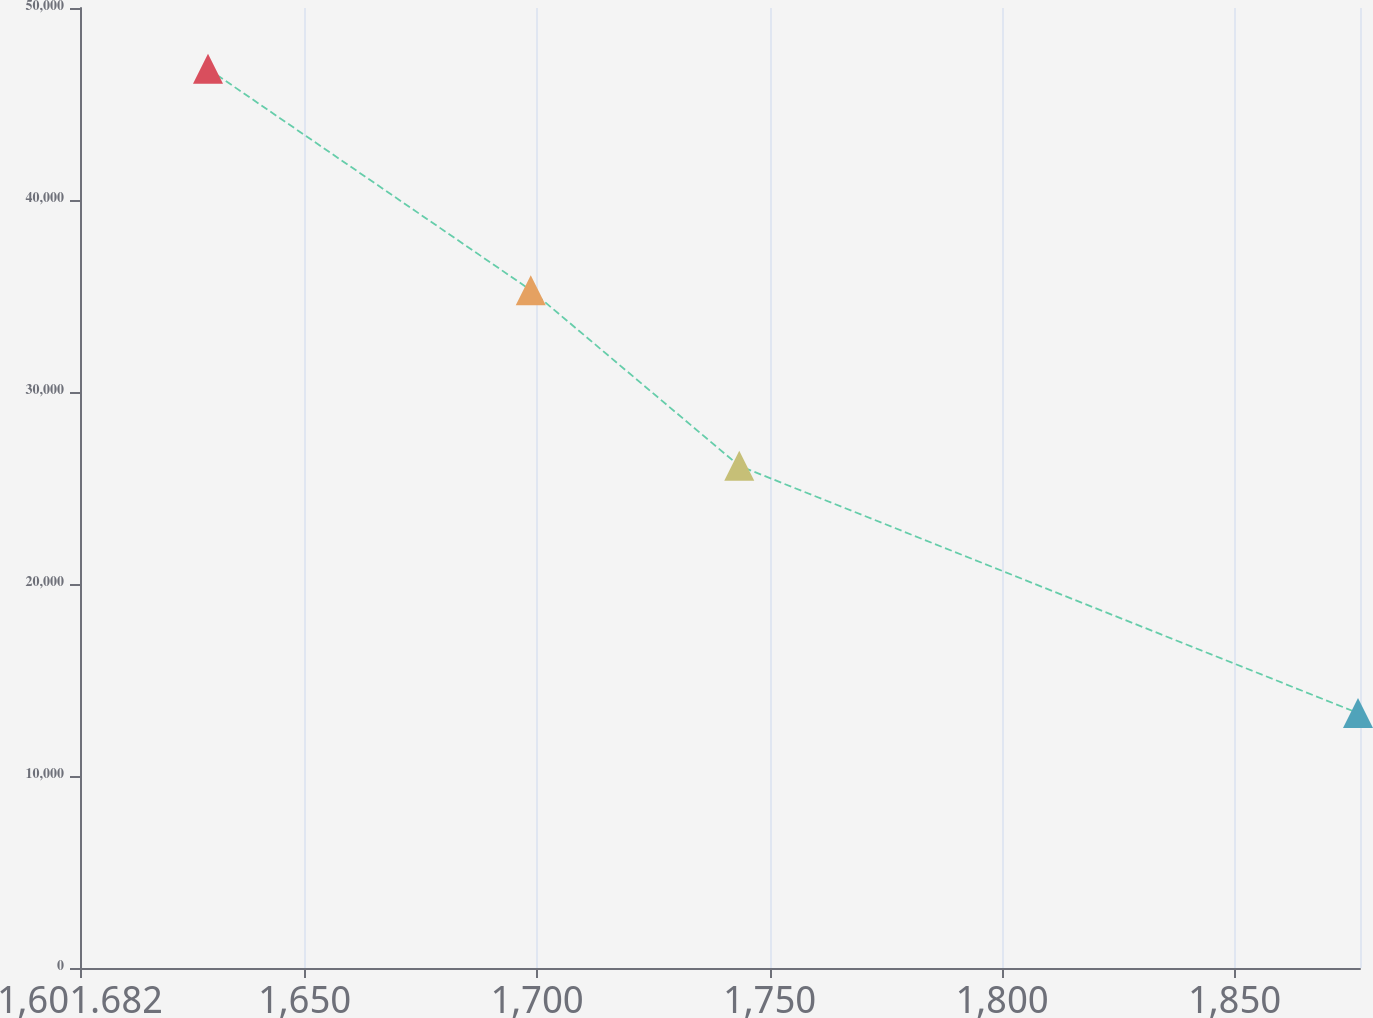Convert chart to OTSL. <chart><loc_0><loc_0><loc_500><loc_500><line_chart><ecel><fcel>Lease Payments (In thousands)<nl><fcel>1629.21<fcel>46833.2<nl><fcel>1698.62<fcel>35304.7<nl><fcel>1743.46<fcel>26152.5<nl><fcel>1876.53<fcel>13278.5<nl><fcel>1904.49<fcel>16634<nl></chart> 